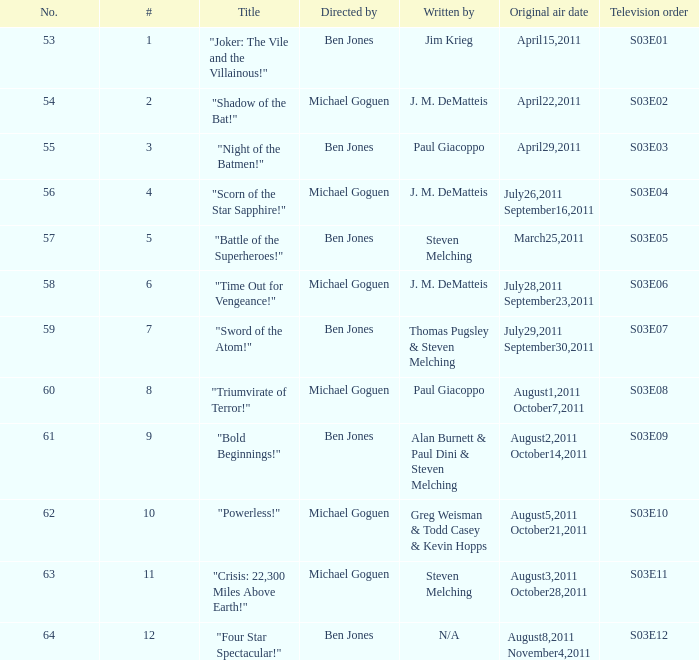What was the original air date for "Crisis: 22,300 Miles Above Earth!"? August3,2011 October28,2011. Give me the full table as a dictionary. {'header': ['No.', '#', 'Title', 'Directed by', 'Written by', 'Original air date', 'Television order'], 'rows': [['53', '1', '"Joker: The Vile and the Villainous!"', 'Ben Jones', 'Jim Krieg', 'April15,2011', 'S03E01'], ['54', '2', '"Shadow of the Bat!"', 'Michael Goguen', 'J. M. DeMatteis', 'April22,2011', 'S03E02'], ['55', '3', '"Night of the Batmen!"', 'Ben Jones', 'Paul Giacoppo', 'April29,2011', 'S03E03'], ['56', '4', '"Scorn of the Star Sapphire!"', 'Michael Goguen', 'J. M. DeMatteis', 'July26,2011 September16,2011', 'S03E04'], ['57', '5', '"Battle of the Superheroes!"', 'Ben Jones', 'Steven Melching', 'March25,2011', 'S03E05'], ['58', '6', '"Time Out for Vengeance!"', 'Michael Goguen', 'J. M. DeMatteis', 'July28,2011 September23,2011', 'S03E06'], ['59', '7', '"Sword of the Atom!"', 'Ben Jones', 'Thomas Pugsley & Steven Melching', 'July29,2011 September30,2011', 'S03E07'], ['60', '8', '"Triumvirate of Terror!"', 'Michael Goguen', 'Paul Giacoppo', 'August1,2011 October7,2011', 'S03E08'], ['61', '9', '"Bold Beginnings!"', 'Ben Jones', 'Alan Burnett & Paul Dini & Steven Melching', 'August2,2011 October14,2011', 'S03E09'], ['62', '10', '"Powerless!"', 'Michael Goguen', 'Greg Weisman & Todd Casey & Kevin Hopps', 'August5,2011 October21,2011', 'S03E10'], ['63', '11', '"Crisis: 22,300 Miles Above Earth!"', 'Michael Goguen', 'Steven Melching', 'August3,2011 October28,2011', 'S03E11'], ['64', '12', '"Four Star Spectacular!"', 'Ben Jones', 'N/A', 'August8,2011 November4,2011', 'S03E12']]} 